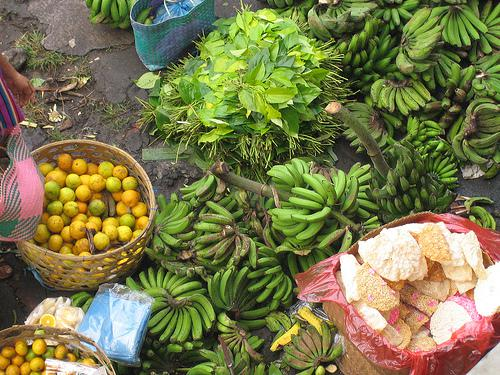Question: what is the green fruit called?
Choices:
A. Apple.
B. Grape.
C. Orange.
D. Bananas.
Answer with the letter. Answer: D Question: where are the bananas sitting?
Choices:
A. The table.
B. In the bowl.
C. The ground.
D. On the counter.
Answer with the letter. Answer: C Question: how is the banana eaten?
Choices:
A. Peel removed.
B. With the peel on.
C. With a knife and fork.
D. Bananas are not food.
Answer with the letter. Answer: A 